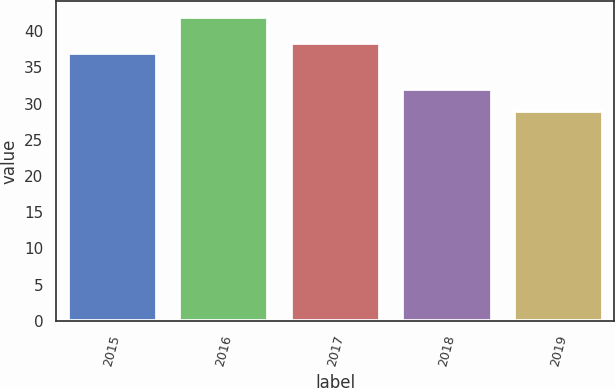<chart> <loc_0><loc_0><loc_500><loc_500><bar_chart><fcel>2015<fcel>2016<fcel>2017<fcel>2018<fcel>2019<nl><fcel>37<fcel>42<fcel>38.3<fcel>32<fcel>29<nl></chart> 